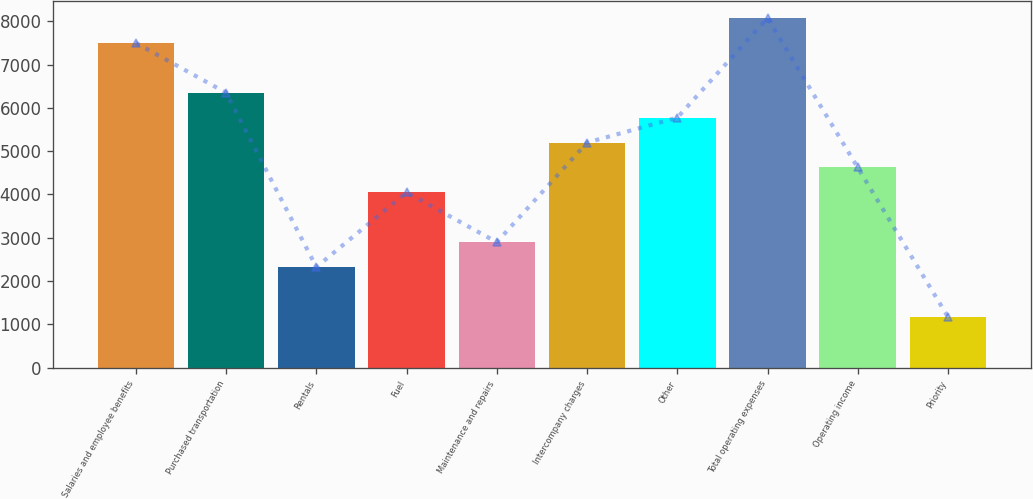Convert chart to OTSL. <chart><loc_0><loc_0><loc_500><loc_500><bar_chart><fcel>Salaries and employee benefits<fcel>Purchased transportation<fcel>Rentals<fcel>Fuel<fcel>Maintenance and repairs<fcel>Intercompany charges<fcel>Other<fcel>Total operating expenses<fcel>Operating income<fcel>Priority<nl><fcel>7500.32<fcel>6349.46<fcel>2321.45<fcel>4047.74<fcel>2896.88<fcel>5198.6<fcel>5774.03<fcel>8075.75<fcel>4623.17<fcel>1170.59<nl></chart> 